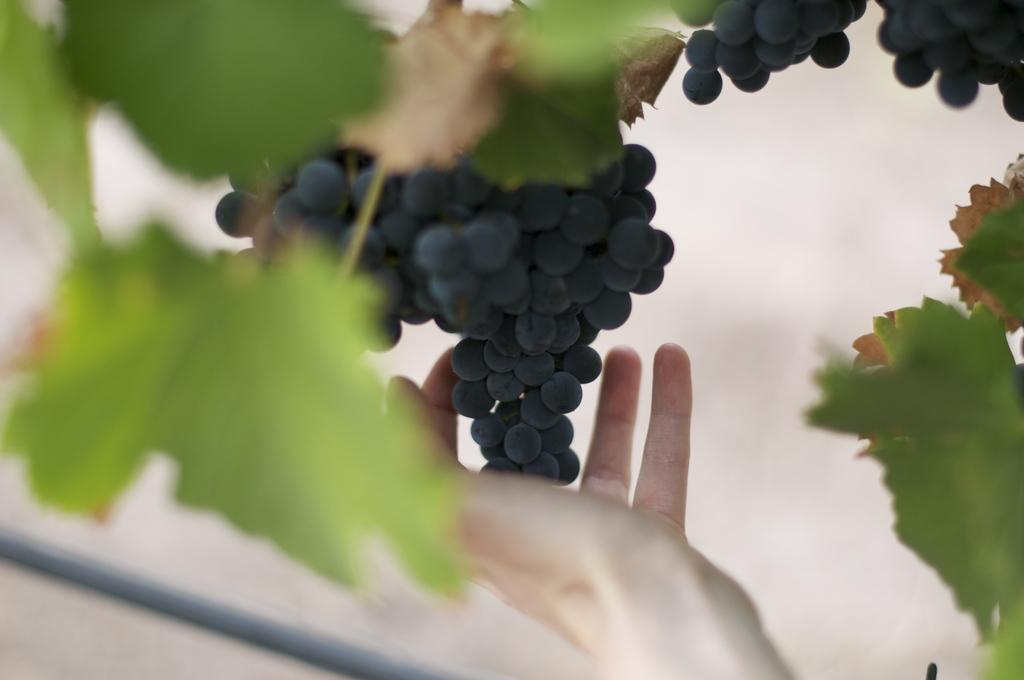What type of fruit is visible in the image? There is a bunch of grapes in the image. Whose hand can be seen in the image? A person's hand is visible in the image. What else is present in the image besides the grapes and hand? There are leaves in the image. What type of bushes are used to cover the person's cough in the image? There are no bushes or coughing person present in the image. 